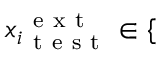Convert formula to latex. <formula><loc_0><loc_0><loc_500><loc_500>{ x _ { i } } _ { t e s t } ^ { e x t } \in \{</formula> 